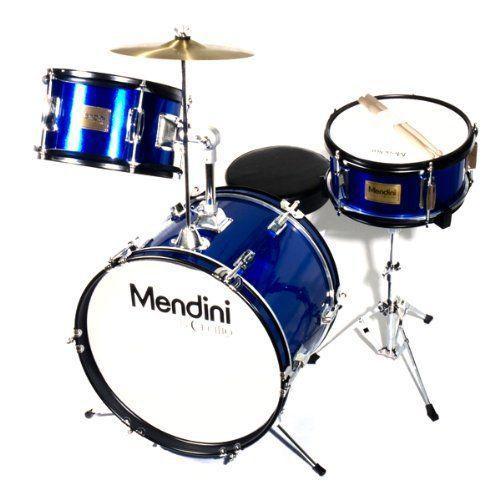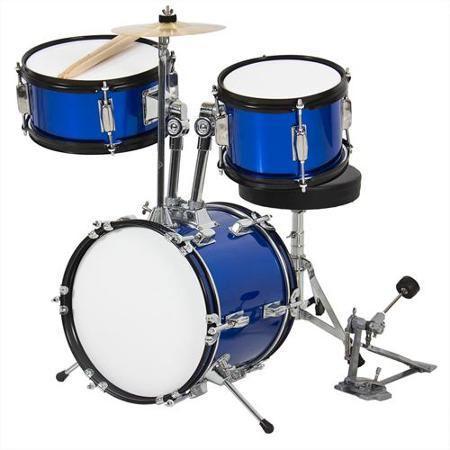The first image is the image on the left, the second image is the image on the right. Examine the images to the left and right. Is the description "One of the kick drums has a black front." accurate? Answer yes or no. No. The first image is the image on the left, the second image is the image on the right. For the images displayed, is the sentence "The drumkit on the right has a large drum positioned on its side with a black face showing, and the drumkit on the left has a large drum with a white face." factually correct? Answer yes or no. No. 